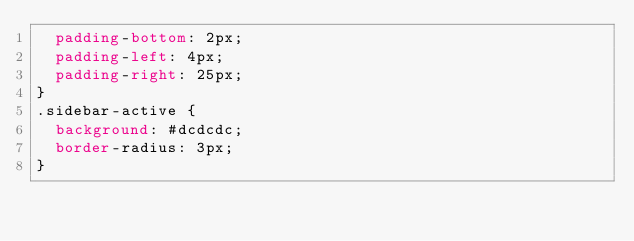<code> <loc_0><loc_0><loc_500><loc_500><_CSS_>  padding-bottom: 2px;
  padding-left: 4px;
  padding-right: 25px;
}
.sidebar-active {
  background: #dcdcdc;
  border-radius: 3px;
}

</code> 